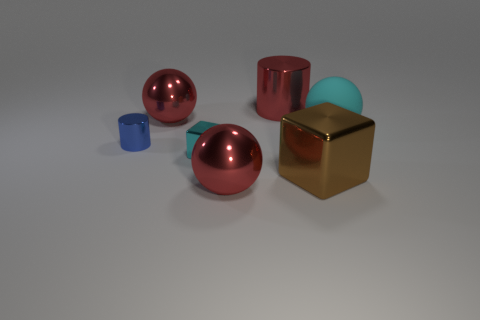Add 1 matte spheres. How many objects exist? 8 Subtract all cyan balls. How many balls are left? 2 Subtract all cyan balls. How many balls are left? 2 Subtract all blocks. How many objects are left? 5 Subtract 0 blue cubes. How many objects are left? 7 Subtract 2 cubes. How many cubes are left? 0 Subtract all cyan blocks. Subtract all cyan balls. How many blocks are left? 1 Subtract all yellow cubes. How many cyan balls are left? 1 Subtract all cyan metallic cubes. Subtract all big red shiny cubes. How many objects are left? 6 Add 7 small cyan objects. How many small cyan objects are left? 8 